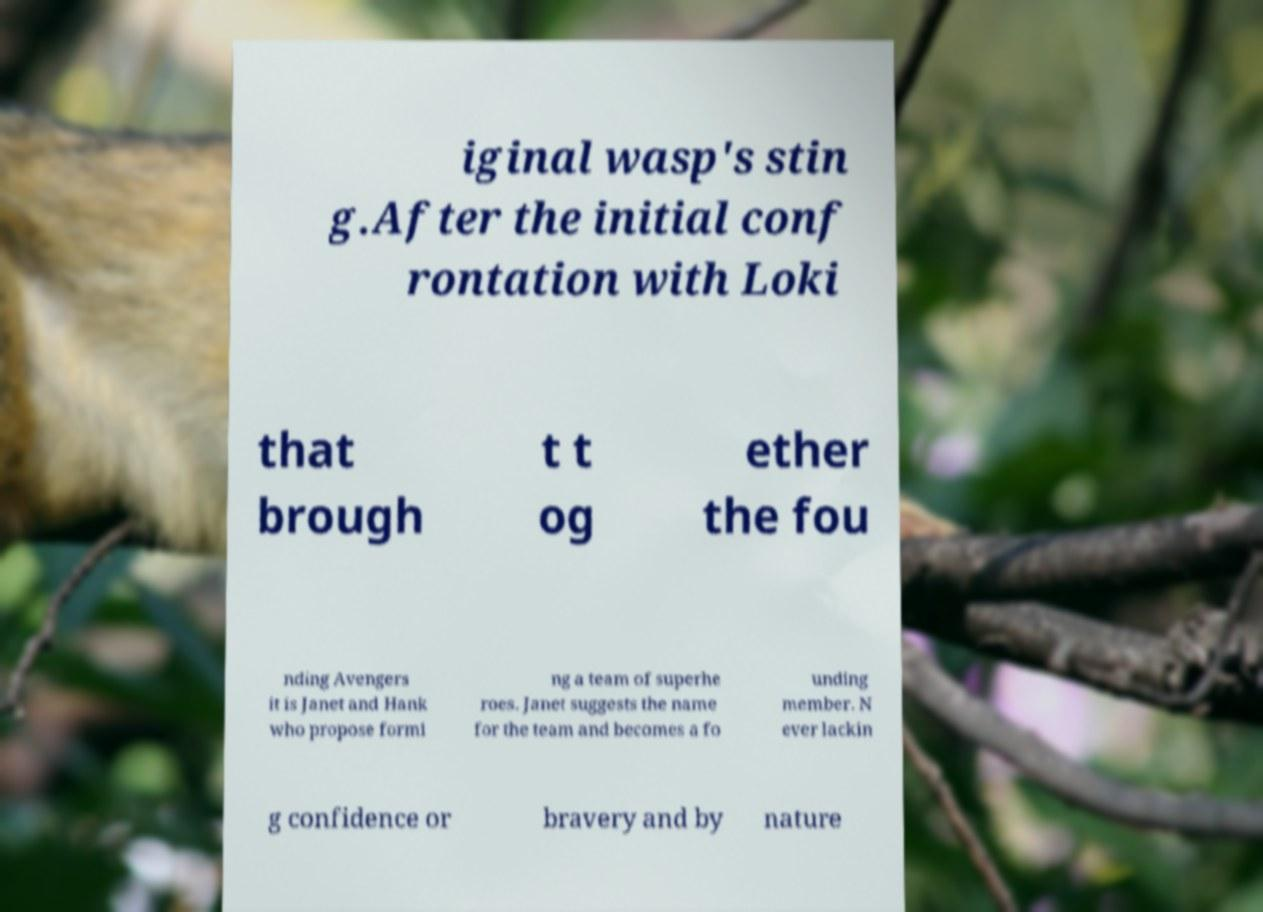Can you read and provide the text displayed in the image?This photo seems to have some interesting text. Can you extract and type it out for me? iginal wasp's stin g.After the initial conf rontation with Loki that brough t t og ether the fou nding Avengers it is Janet and Hank who propose formi ng a team of superhe roes. Janet suggests the name for the team and becomes a fo unding member. N ever lackin g confidence or bravery and by nature 